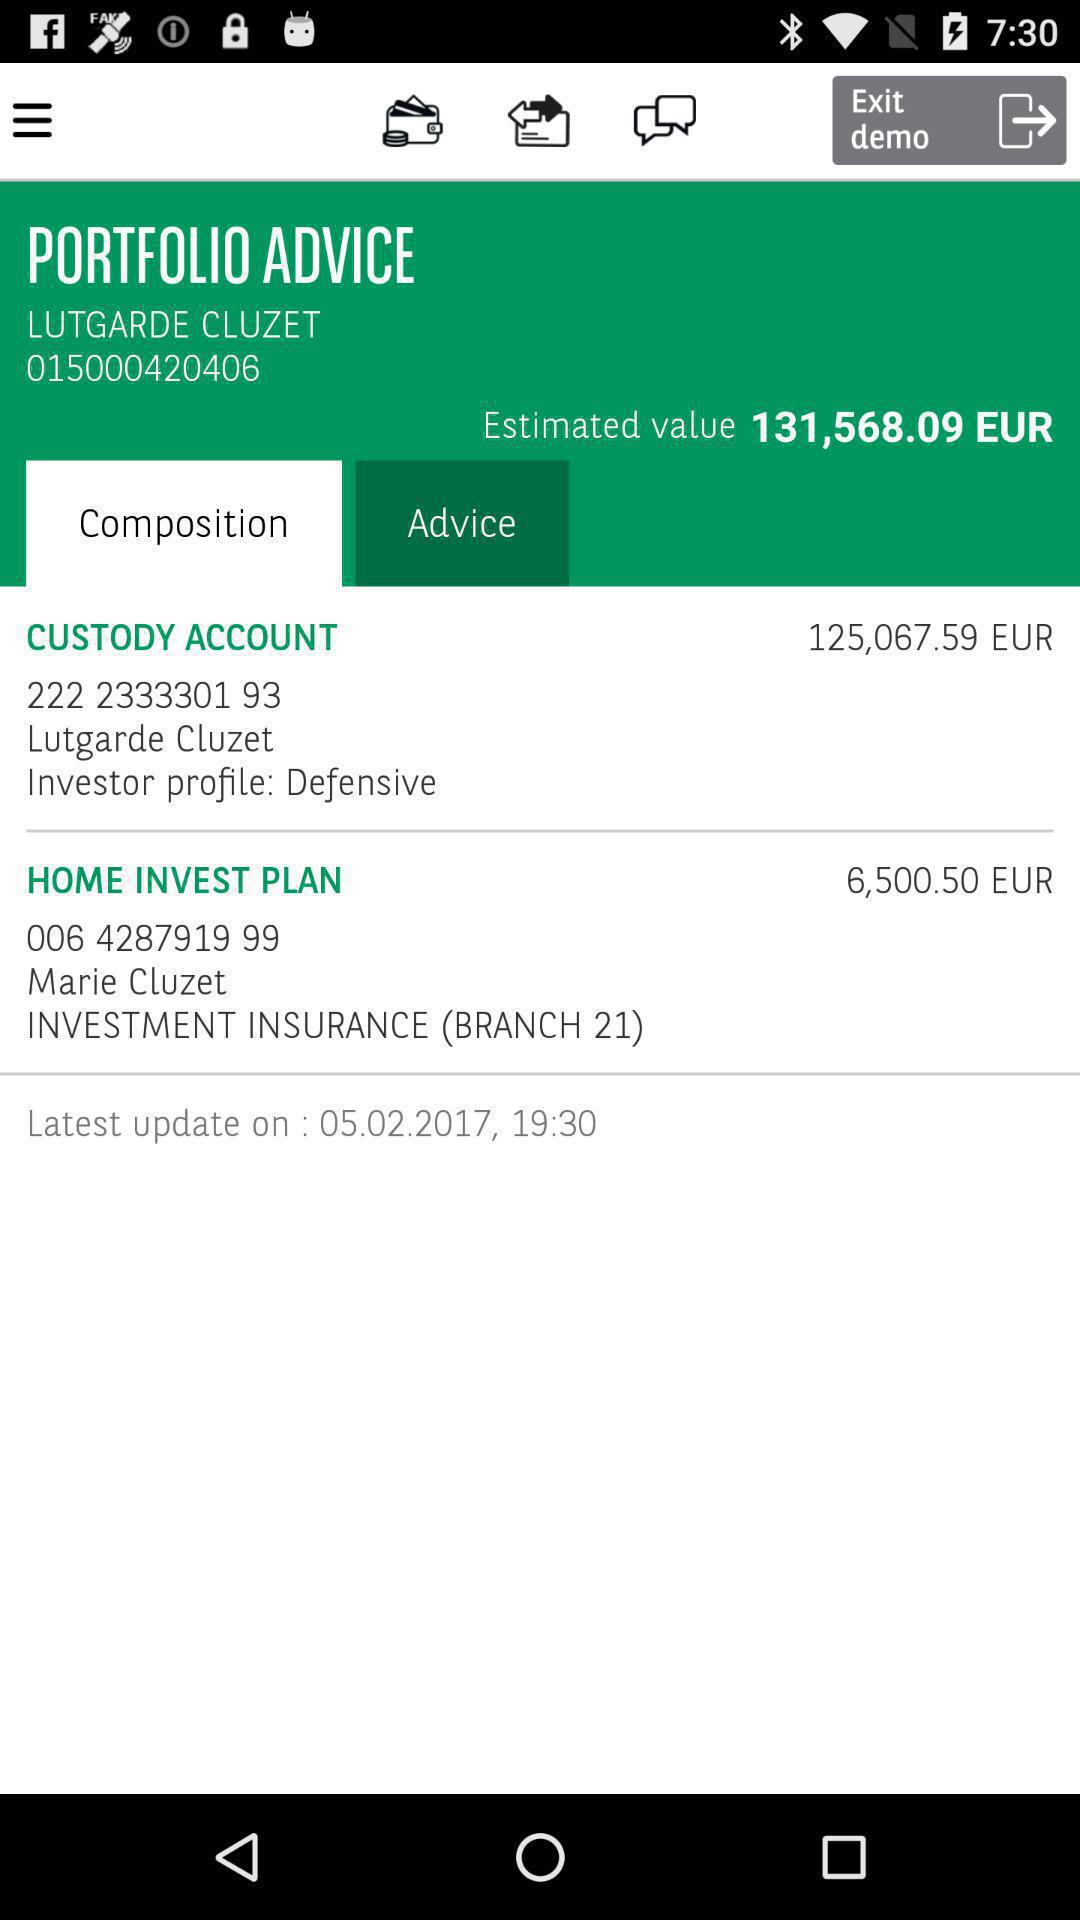What is the date and time for the latest update? The date and time for the latest update is February 5, 2017 at 19:30. 